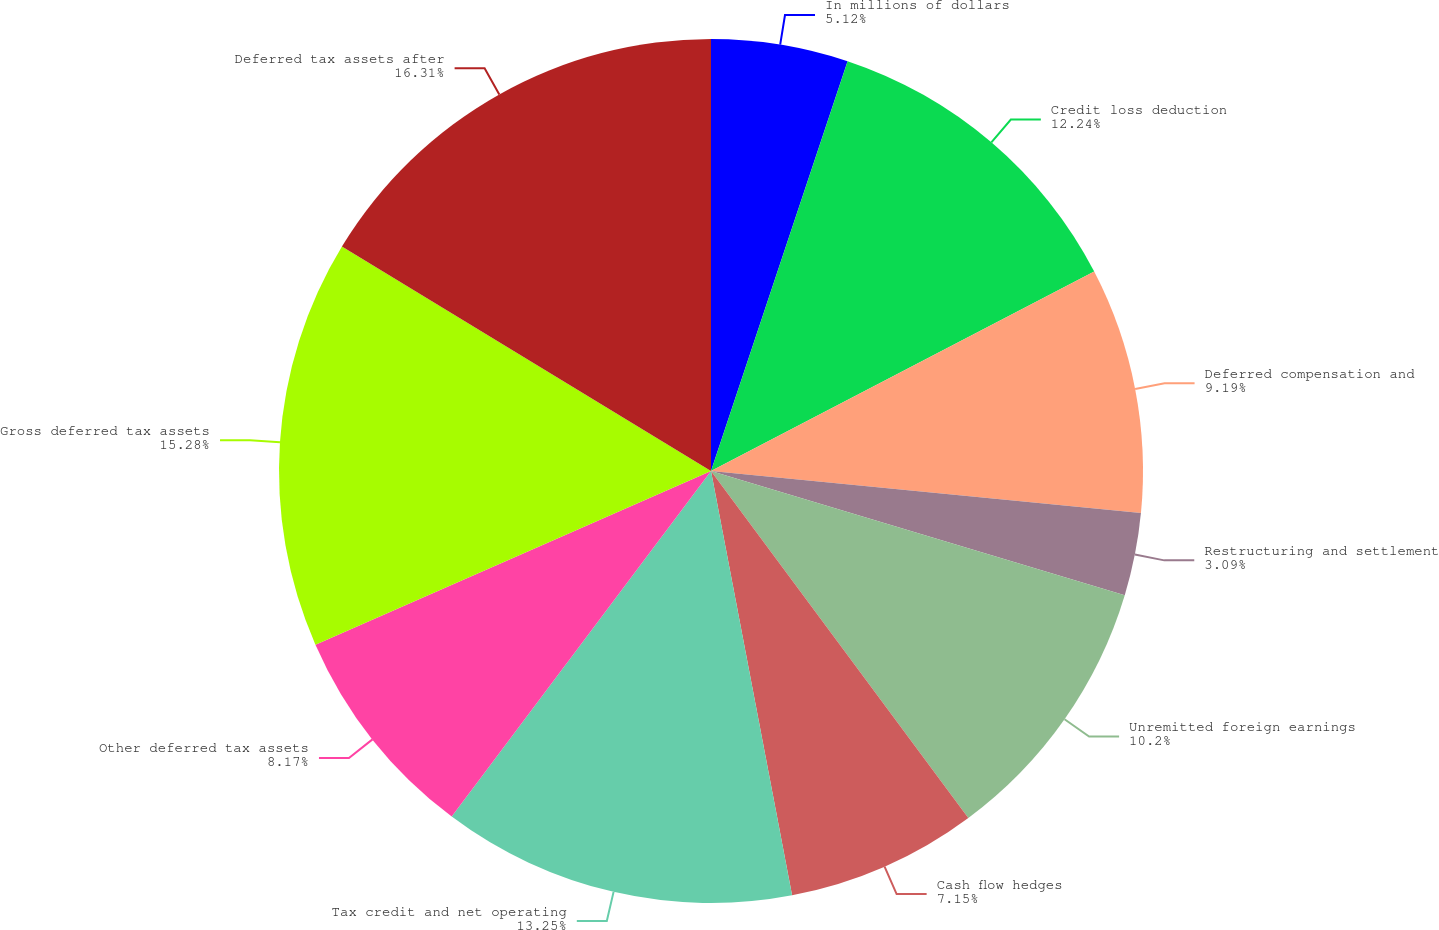<chart> <loc_0><loc_0><loc_500><loc_500><pie_chart><fcel>In millions of dollars<fcel>Credit loss deduction<fcel>Deferred compensation and<fcel>Restructuring and settlement<fcel>Unremitted foreign earnings<fcel>Cash flow hedges<fcel>Tax credit and net operating<fcel>Other deferred tax assets<fcel>Gross deferred tax assets<fcel>Deferred tax assets after<nl><fcel>5.12%<fcel>12.24%<fcel>9.19%<fcel>3.09%<fcel>10.2%<fcel>7.15%<fcel>13.25%<fcel>8.17%<fcel>15.28%<fcel>16.3%<nl></chart> 